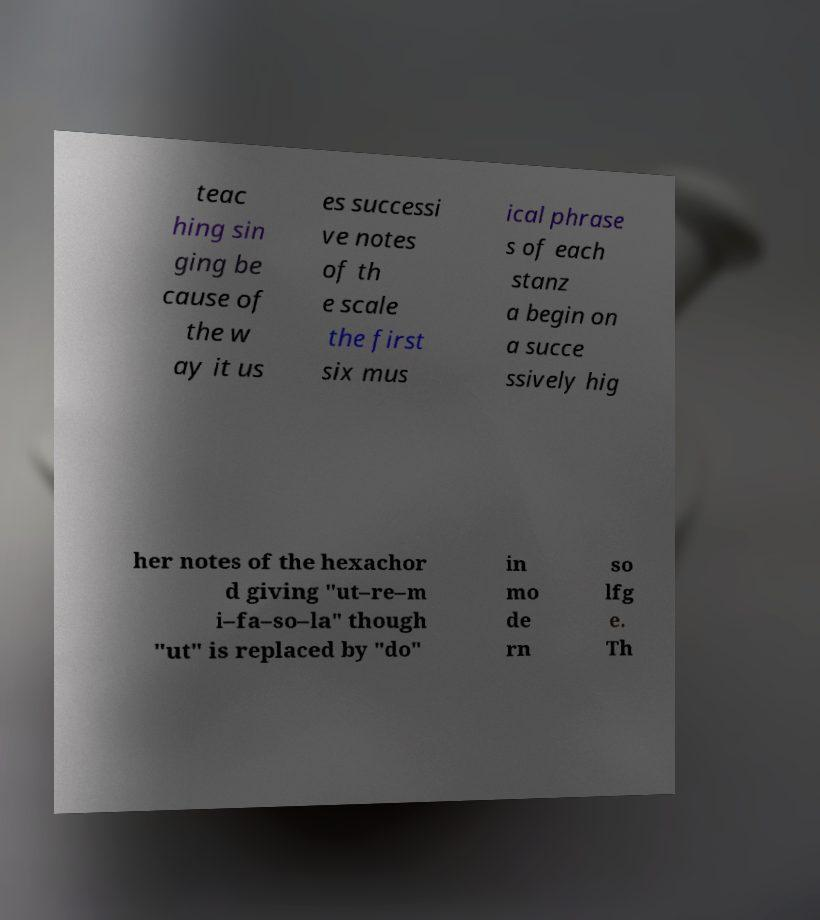I need the written content from this picture converted into text. Can you do that? teac hing sin ging be cause of the w ay it us es successi ve notes of th e scale the first six mus ical phrase s of each stanz a begin on a succe ssively hig her notes of the hexachor d giving "ut–re–m i–fa–so–la" though "ut" is replaced by "do" in mo de rn so lfg e. Th 